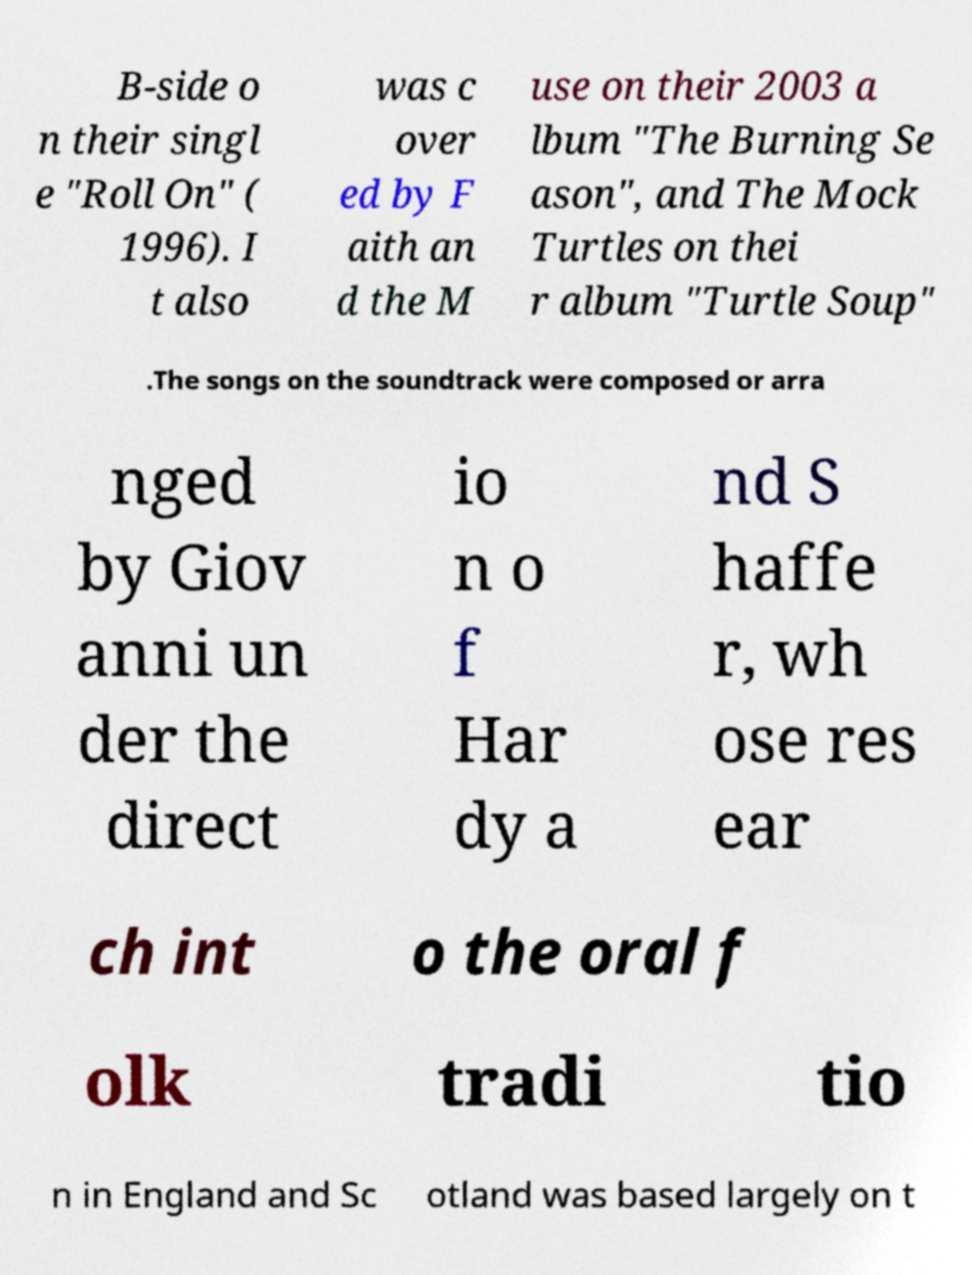Can you read and provide the text displayed in the image?This photo seems to have some interesting text. Can you extract and type it out for me? B-side o n their singl e "Roll On" ( 1996). I t also was c over ed by F aith an d the M use on their 2003 a lbum "The Burning Se ason", and The Mock Turtles on thei r album "Turtle Soup" .The songs on the soundtrack were composed or arra nged by Giov anni un der the direct io n o f Har dy a nd S haffe r, wh ose res ear ch int o the oral f olk tradi tio n in England and Sc otland was based largely on t 